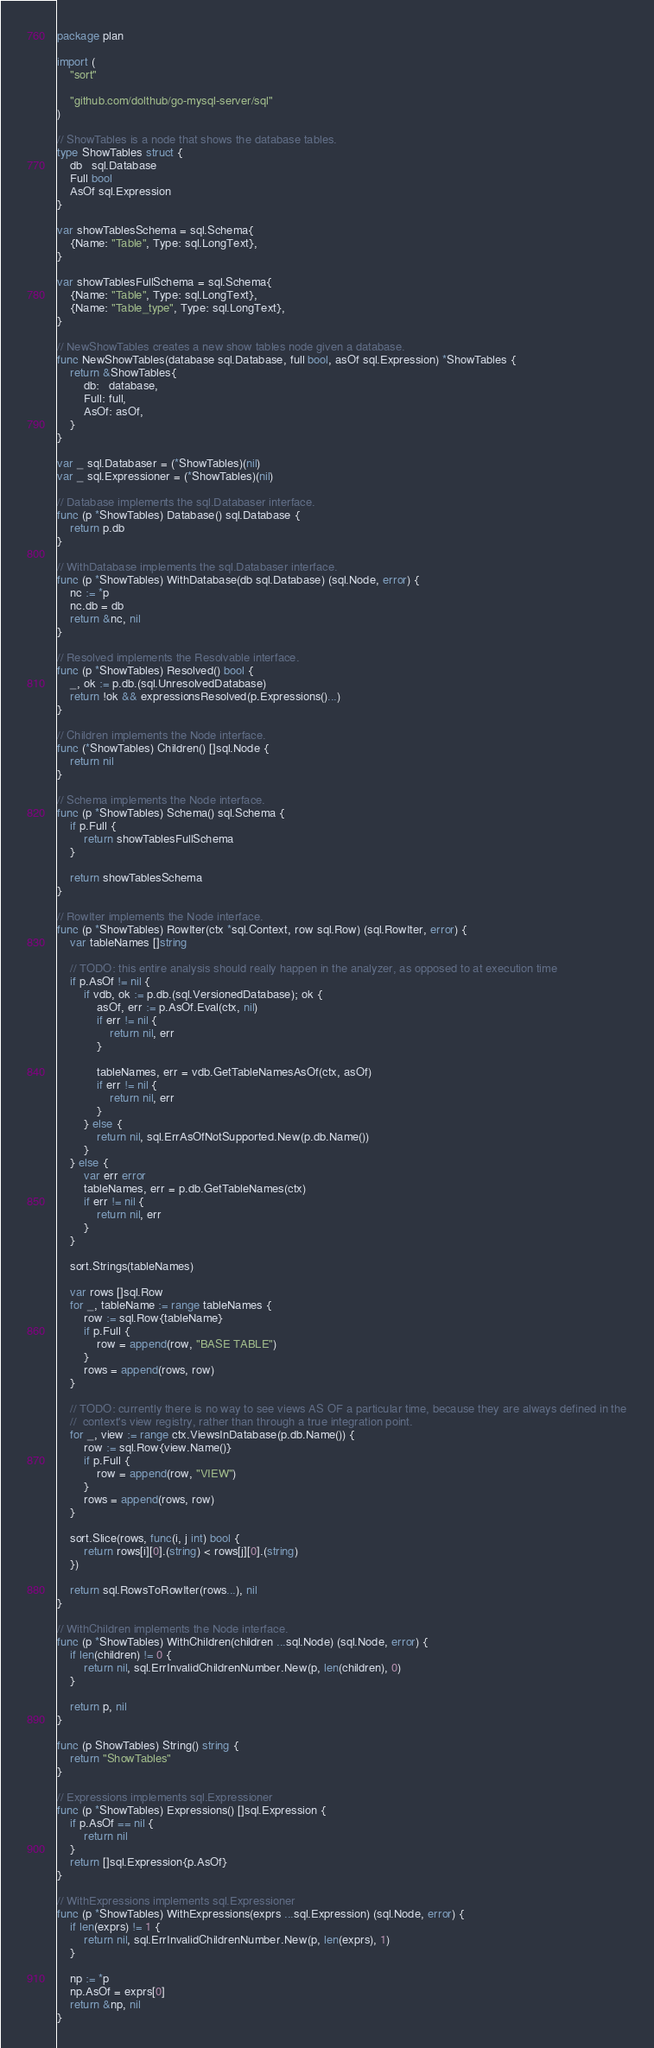<code> <loc_0><loc_0><loc_500><loc_500><_Go_>package plan

import (
	"sort"

	"github.com/dolthub/go-mysql-server/sql"
)

// ShowTables is a node that shows the database tables.
type ShowTables struct {
	db   sql.Database
	Full bool
	AsOf sql.Expression
}

var showTablesSchema = sql.Schema{
	{Name: "Table", Type: sql.LongText},
}

var showTablesFullSchema = sql.Schema{
	{Name: "Table", Type: sql.LongText},
	{Name: "Table_type", Type: sql.LongText},
}

// NewShowTables creates a new show tables node given a database.
func NewShowTables(database sql.Database, full bool, asOf sql.Expression) *ShowTables {
	return &ShowTables{
		db:   database,
		Full: full,
		AsOf: asOf,
	}
}

var _ sql.Databaser = (*ShowTables)(nil)
var _ sql.Expressioner = (*ShowTables)(nil)

// Database implements the sql.Databaser interface.
func (p *ShowTables) Database() sql.Database {
	return p.db
}

// WithDatabase implements the sql.Databaser interface.
func (p *ShowTables) WithDatabase(db sql.Database) (sql.Node, error) {
	nc := *p
	nc.db = db
	return &nc, nil
}

// Resolved implements the Resolvable interface.
func (p *ShowTables) Resolved() bool {
	_, ok := p.db.(sql.UnresolvedDatabase)
	return !ok && expressionsResolved(p.Expressions()...)
}

// Children implements the Node interface.
func (*ShowTables) Children() []sql.Node {
	return nil
}

// Schema implements the Node interface.
func (p *ShowTables) Schema() sql.Schema {
	if p.Full {
		return showTablesFullSchema
	}

	return showTablesSchema
}

// RowIter implements the Node interface.
func (p *ShowTables) RowIter(ctx *sql.Context, row sql.Row) (sql.RowIter, error) {
	var tableNames []string

	// TODO: this entire analysis should really happen in the analyzer, as opposed to at execution time
	if p.AsOf != nil {
		if vdb, ok := p.db.(sql.VersionedDatabase); ok {
			asOf, err := p.AsOf.Eval(ctx, nil)
			if err != nil {
				return nil, err
			}

			tableNames, err = vdb.GetTableNamesAsOf(ctx, asOf)
			if err != nil {
				return nil, err
			}
		} else {
			return nil, sql.ErrAsOfNotSupported.New(p.db.Name())
		}
	} else {
		var err error
		tableNames, err = p.db.GetTableNames(ctx)
		if err != nil {
			return nil, err
		}
	}

	sort.Strings(tableNames)

	var rows []sql.Row
	for _, tableName := range tableNames {
		row := sql.Row{tableName}
		if p.Full {
			row = append(row, "BASE TABLE")
		}
		rows = append(rows, row)
	}

	// TODO: currently there is no way to see views AS OF a particular time, because they are always defined in the
	//  context's view registry, rather than through a true integration point.
	for _, view := range ctx.ViewsInDatabase(p.db.Name()) {
		row := sql.Row{view.Name()}
		if p.Full {
			row = append(row, "VIEW")
		}
		rows = append(rows, row)
	}

	sort.Slice(rows, func(i, j int) bool {
		return rows[i][0].(string) < rows[j][0].(string)
	})

	return sql.RowsToRowIter(rows...), nil
}

// WithChildren implements the Node interface.
func (p *ShowTables) WithChildren(children ...sql.Node) (sql.Node, error) {
	if len(children) != 0 {
		return nil, sql.ErrInvalidChildrenNumber.New(p, len(children), 0)
	}

	return p, nil
}

func (p ShowTables) String() string {
	return "ShowTables"
}

// Expressions implements sql.Expressioner
func (p *ShowTables) Expressions() []sql.Expression {
	if p.AsOf == nil {
		return nil
	}
	return []sql.Expression{p.AsOf}
}

// WithExpressions implements sql.Expressioner
func (p *ShowTables) WithExpressions(exprs ...sql.Expression) (sql.Node, error) {
	if len(exprs) != 1 {
		return nil, sql.ErrInvalidChildrenNumber.New(p, len(exprs), 1)
	}

	np := *p
	np.AsOf = exprs[0]
	return &np, nil
}
</code> 